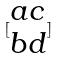<formula> <loc_0><loc_0><loc_500><loc_500>[ \begin{matrix} a c \\ b d \end{matrix} ]</formula> 